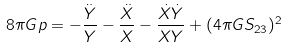Convert formula to latex. <formula><loc_0><loc_0><loc_500><loc_500>8 { \pi } G p = - { \frac { \ddot { Y } } { Y } } - { \frac { \ddot { X } } { X } } - \frac { { \dot { X } } { \dot { Y } } } { X Y } + ( 4 { \pi } G S _ { 2 3 } ) ^ { 2 }</formula> 